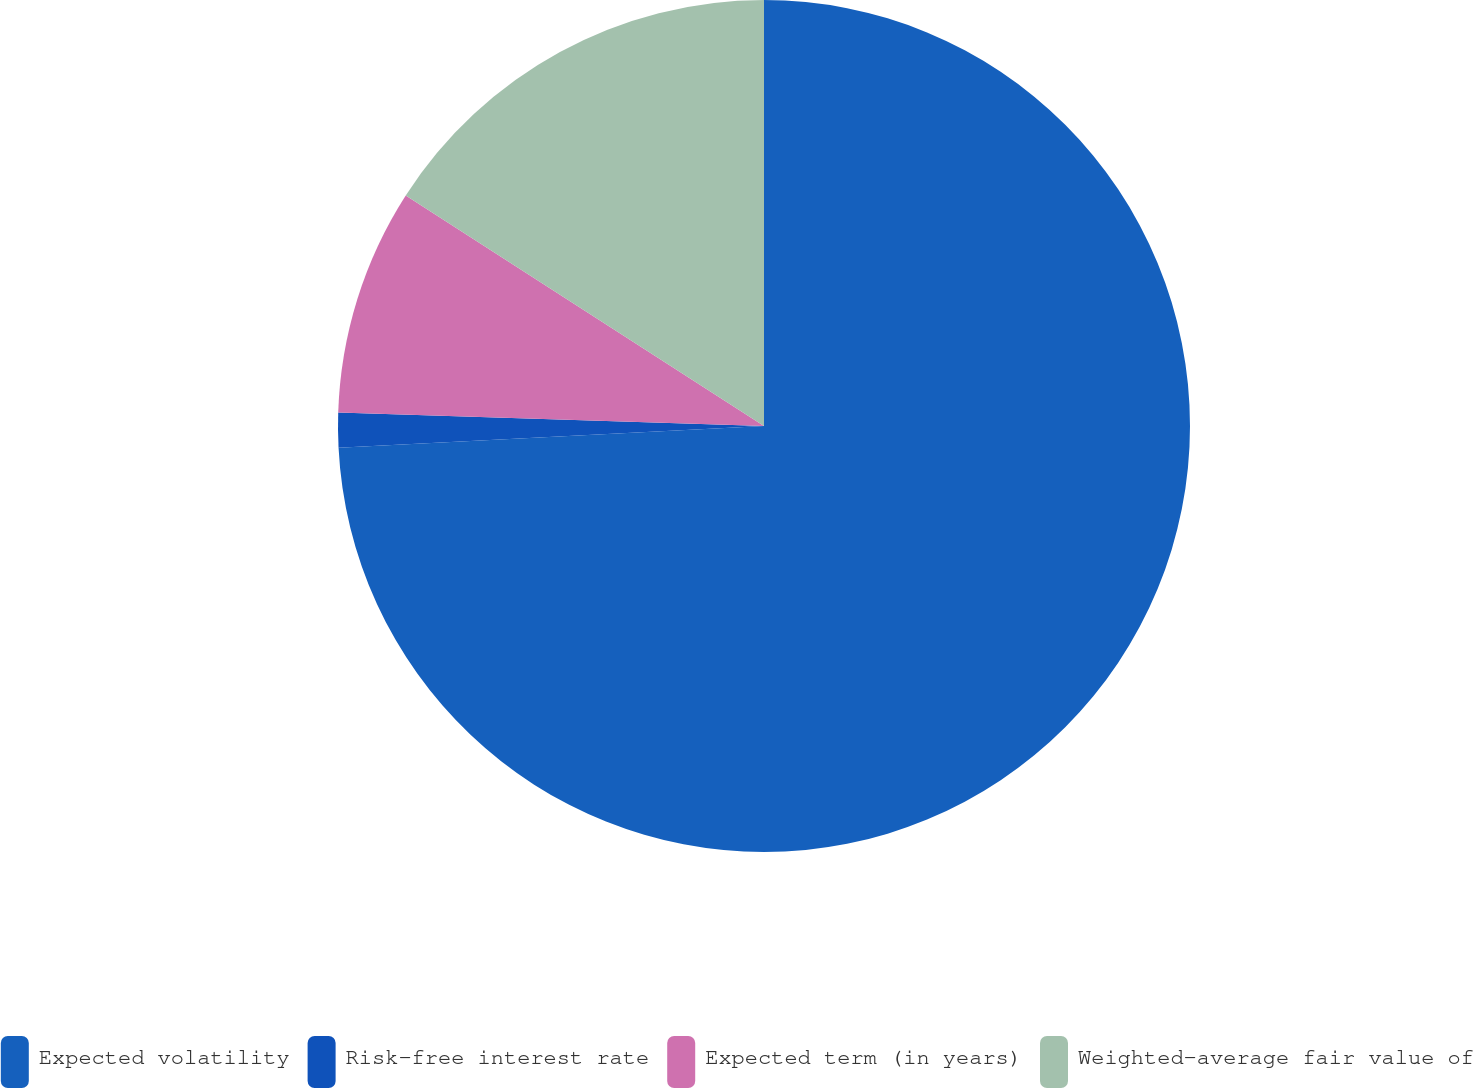Convert chart to OTSL. <chart><loc_0><loc_0><loc_500><loc_500><pie_chart><fcel>Expected volatility<fcel>Risk-free interest rate<fcel>Expected term (in years)<fcel>Weighted-average fair value of<nl><fcel>74.19%<fcel>1.31%<fcel>8.6%<fcel>15.9%<nl></chart> 